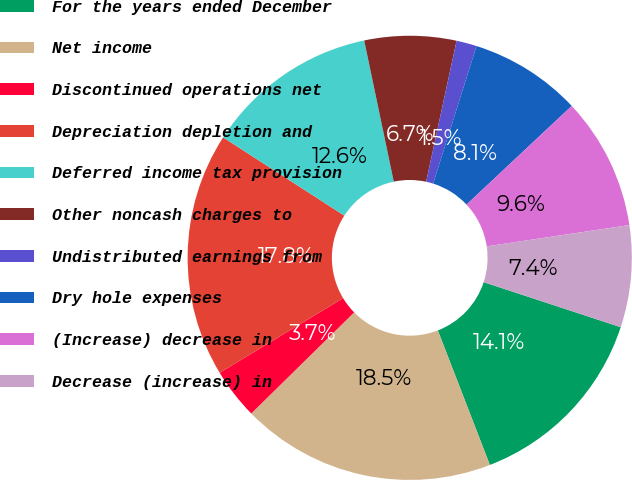Convert chart to OTSL. <chart><loc_0><loc_0><loc_500><loc_500><pie_chart><fcel>For the years ended December<fcel>Net income<fcel>Discontinued operations net<fcel>Depreciation depletion and<fcel>Deferred income tax provision<fcel>Other noncash charges to<fcel>Undistributed earnings from<fcel>Dry hole expenses<fcel>(Increase) decrease in<fcel>Decrease (increase) in<nl><fcel>14.07%<fcel>18.52%<fcel>3.7%<fcel>17.78%<fcel>12.59%<fcel>6.67%<fcel>1.48%<fcel>8.15%<fcel>9.63%<fcel>7.41%<nl></chart> 